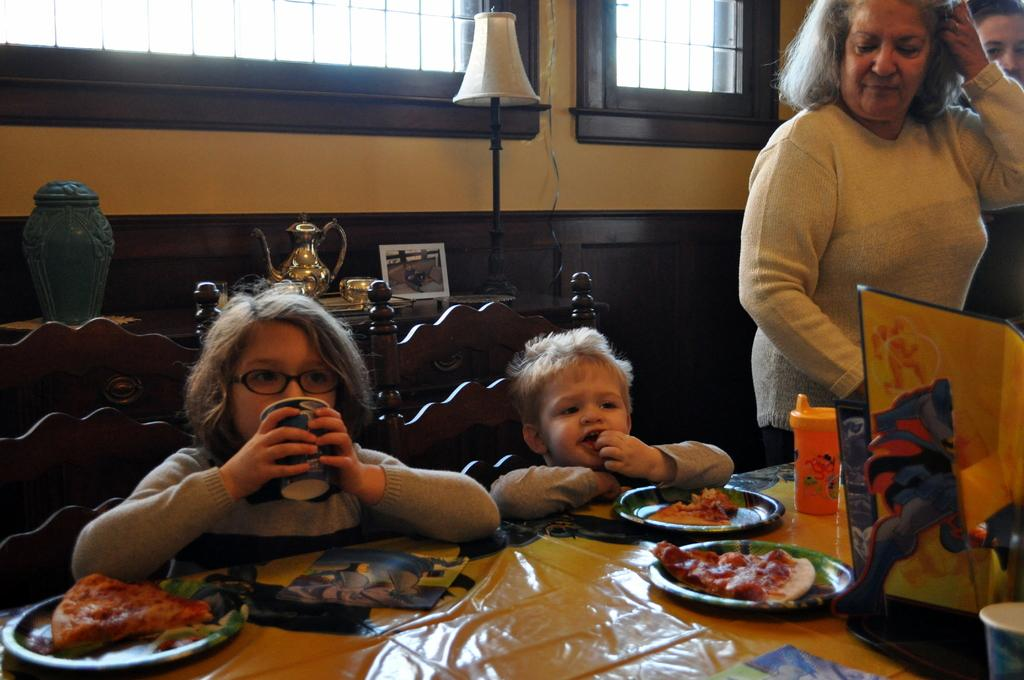Who is present in the image? There are women and two children in the image. What are the children doing in the image? The two children are sitting on a chair. Where is the chair located in relation to the table? The chair is in front of a table. What can be found on the table? There are objects on the table. What type of food is being served at the school in the image? There is no school or food present in the image; it features women and children sitting in front of a table with objects on it. 